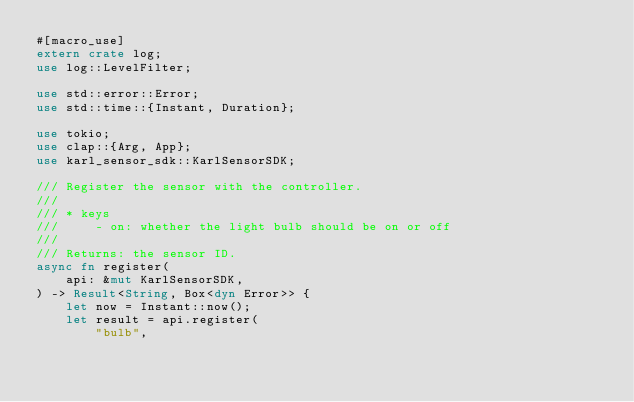Convert code to text. <code><loc_0><loc_0><loc_500><loc_500><_Rust_>#[macro_use]
extern crate log;
use log::LevelFilter;

use std::error::Error;
use std::time::{Instant, Duration};

use tokio;
use clap::{Arg, App};
use karl_sensor_sdk::KarlSensorSDK;

/// Register the sensor with the controller.
///
/// * keys
///     - on: whether the light bulb should be on or off
///
/// Returns: the sensor ID.
async fn register(
    api: &mut KarlSensorSDK,
) -> Result<String, Box<dyn Error>> {
    let now = Instant::now();
    let result = api.register(
        "bulb",</code> 